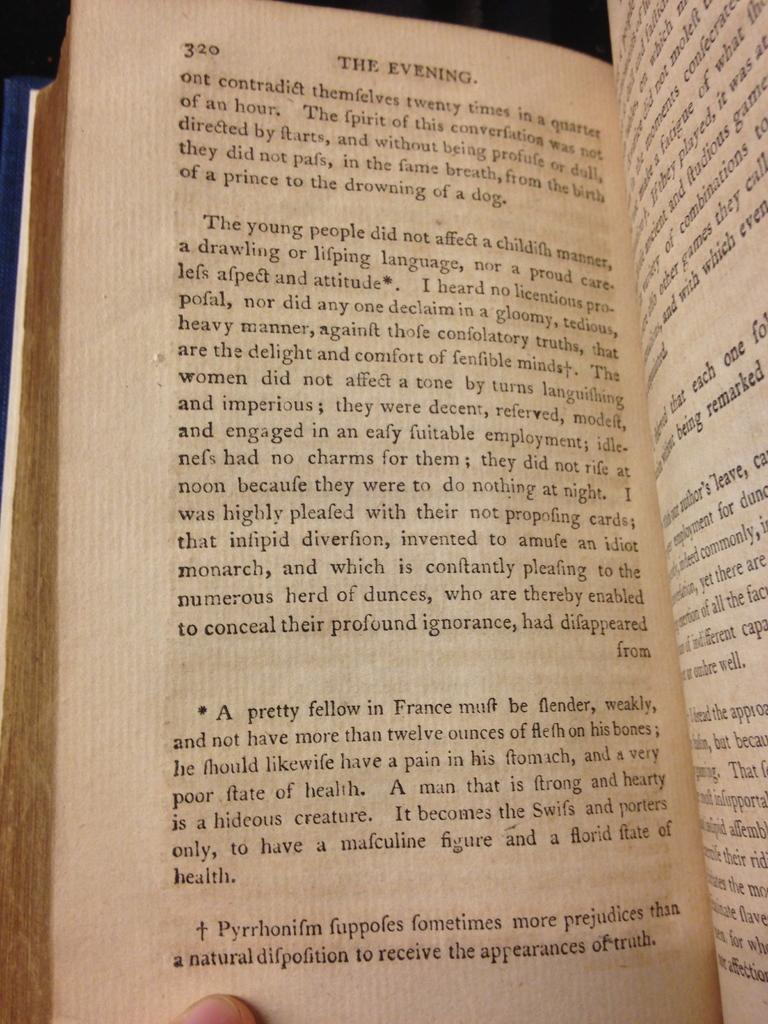<image>
Summarize the visual content of the image. A book is opened to page 320/321 and the first paragraph on page 320 begins with the words "The young people". 